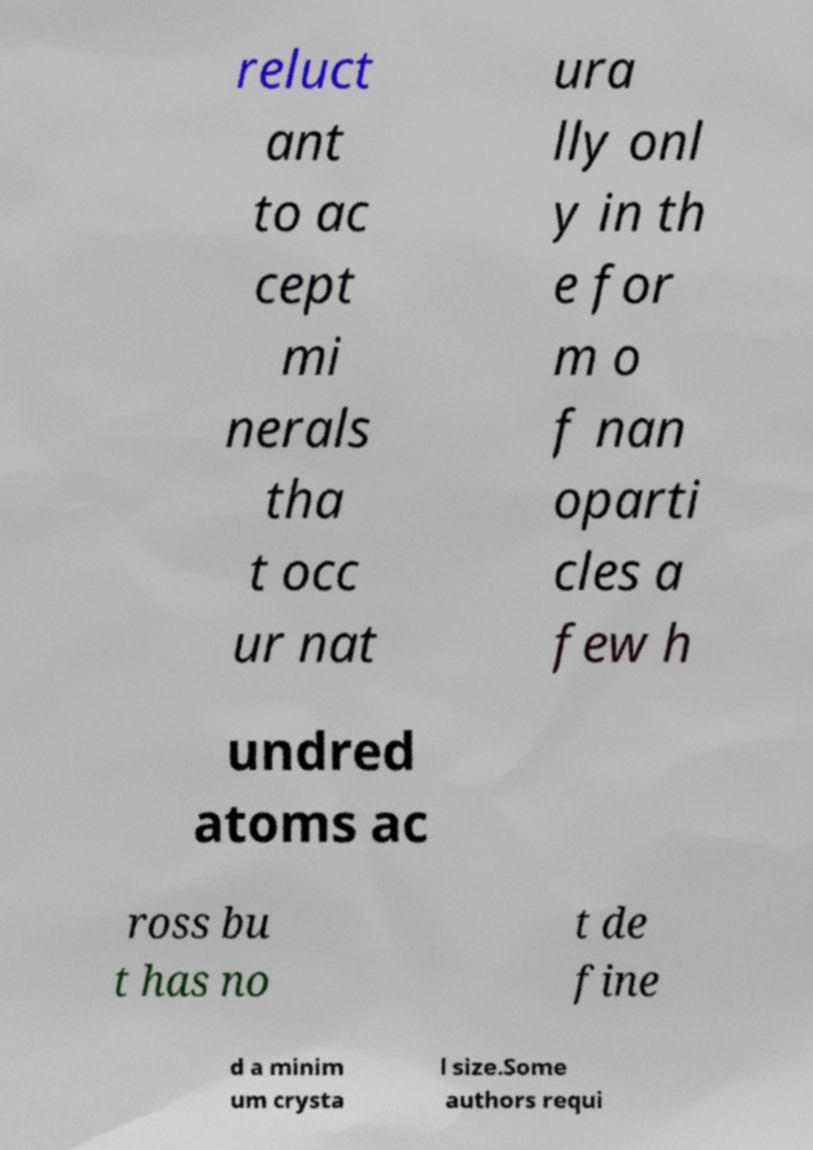I need the written content from this picture converted into text. Can you do that? reluct ant to ac cept mi nerals tha t occ ur nat ura lly onl y in th e for m o f nan oparti cles a few h undred atoms ac ross bu t has no t de fine d a minim um crysta l size.Some authors requi 